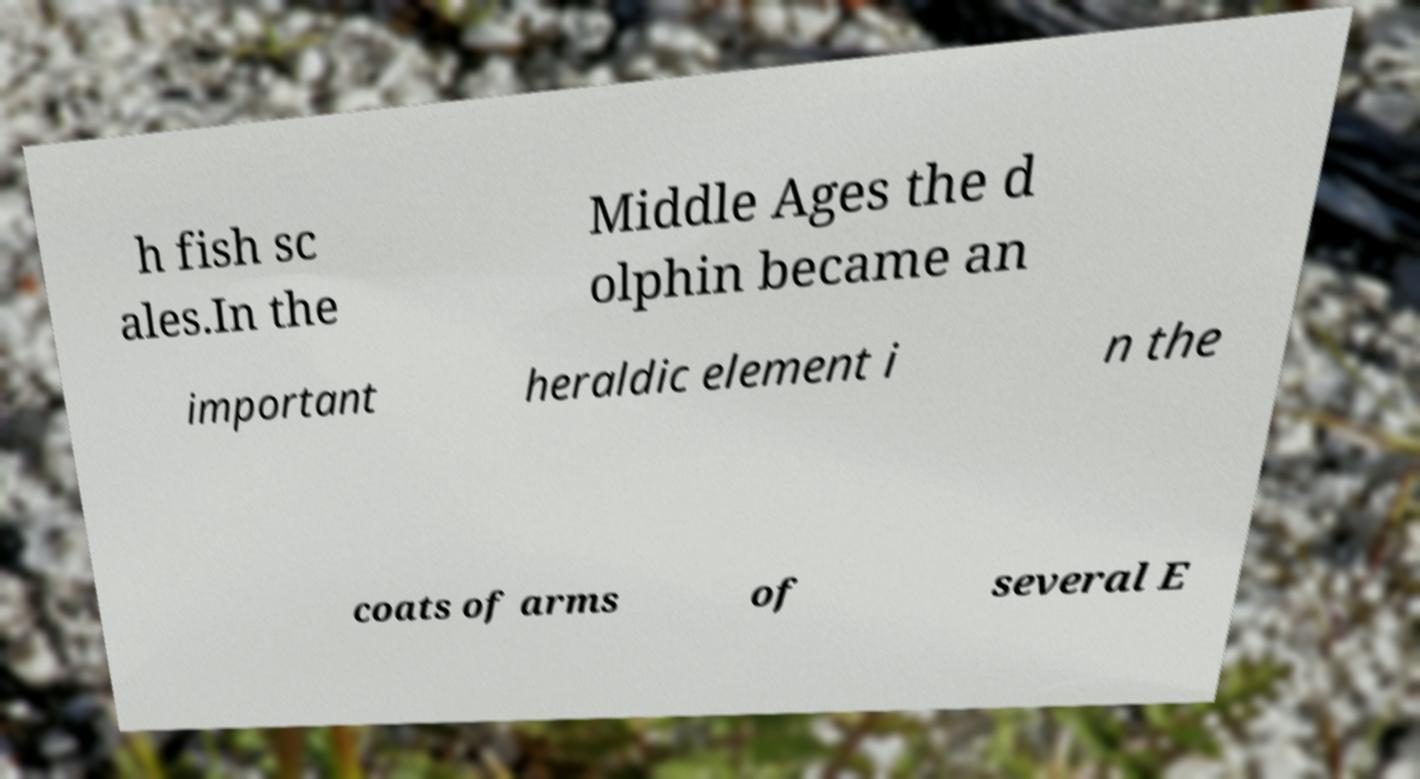For documentation purposes, I need the text within this image transcribed. Could you provide that? h fish sc ales.In the Middle Ages the d olphin became an important heraldic element i n the coats of arms of several E 